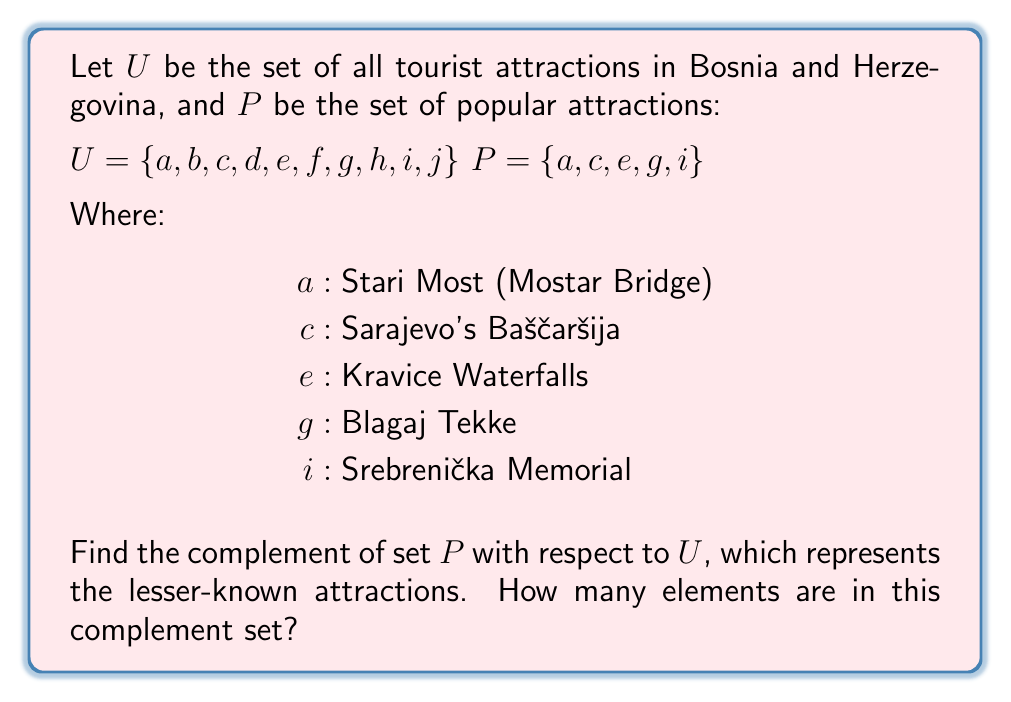Show me your answer to this math problem. To find the complement of set $P$ with respect to $U$, we need to identify all elements in $U$ that are not in $P$. This can be represented mathematically as:

$$P^c = U \setminus P$$

Where $P^c$ is the complement of $P$, and $\setminus$ represents the set difference operation.

Step 1: Identify elements in $U$ that are not in $P$:
$b, d, f, h, j$

Step 2: Form the complement set:
$P^c = \{b, d, f, h, j\}$

Step 3: Count the number of elements in $P^c$:
$|P^c| = 5$

These 5 elements represent the lesser-known attractions in Bosnia and Herzegovina, which would be of interest to a traveler looking for hidden gems.
Answer: 5 